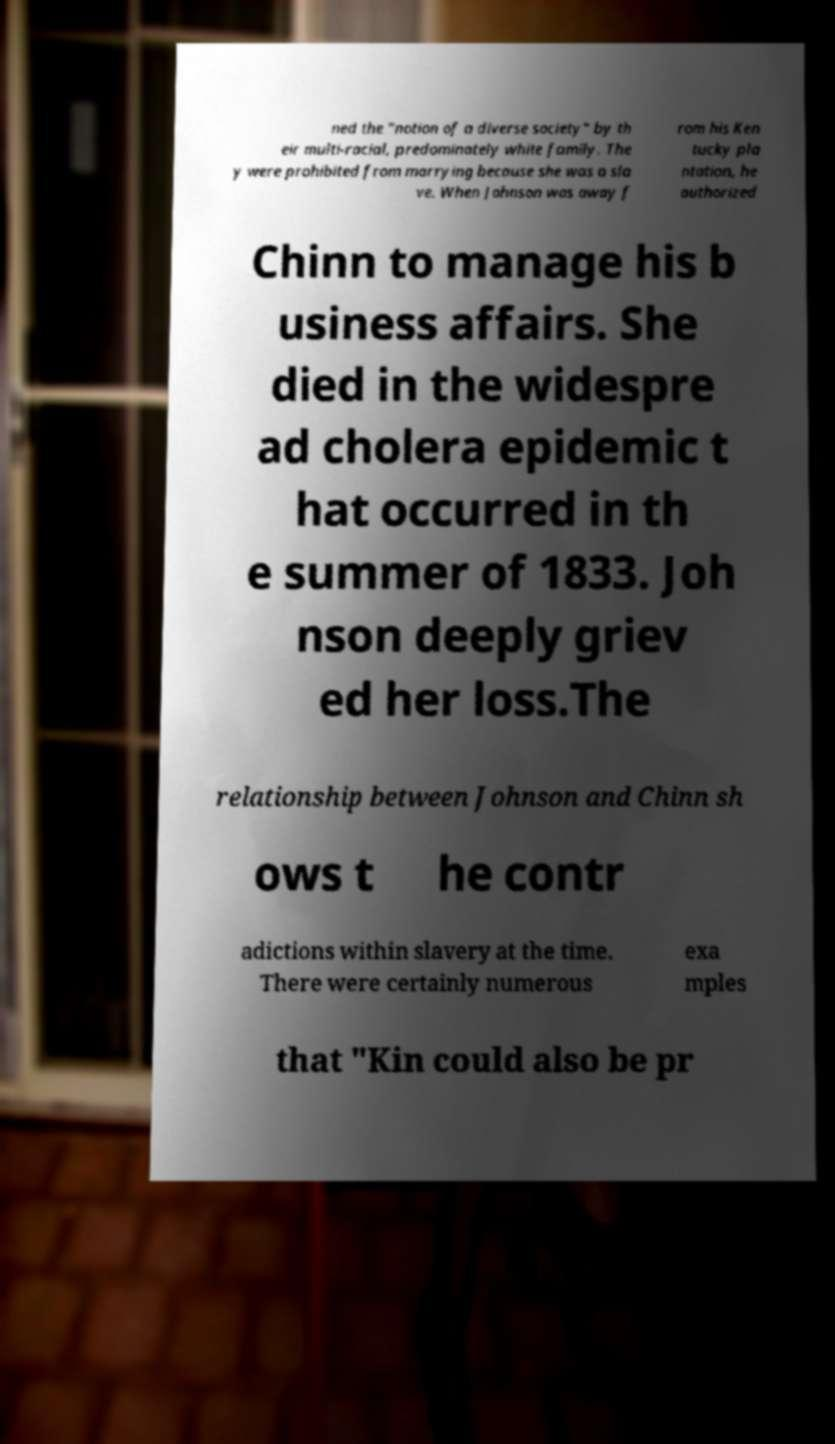Could you extract and type out the text from this image? ned the "notion of a diverse society" by th eir multi-racial, predominately white family. The y were prohibited from marrying because she was a sla ve. When Johnson was away f rom his Ken tucky pla ntation, he authorized Chinn to manage his b usiness affairs. She died in the widespre ad cholera epidemic t hat occurred in th e summer of 1833. Joh nson deeply griev ed her loss.The relationship between Johnson and Chinn sh ows t he contr adictions within slavery at the time. There were certainly numerous exa mples that "Kin could also be pr 